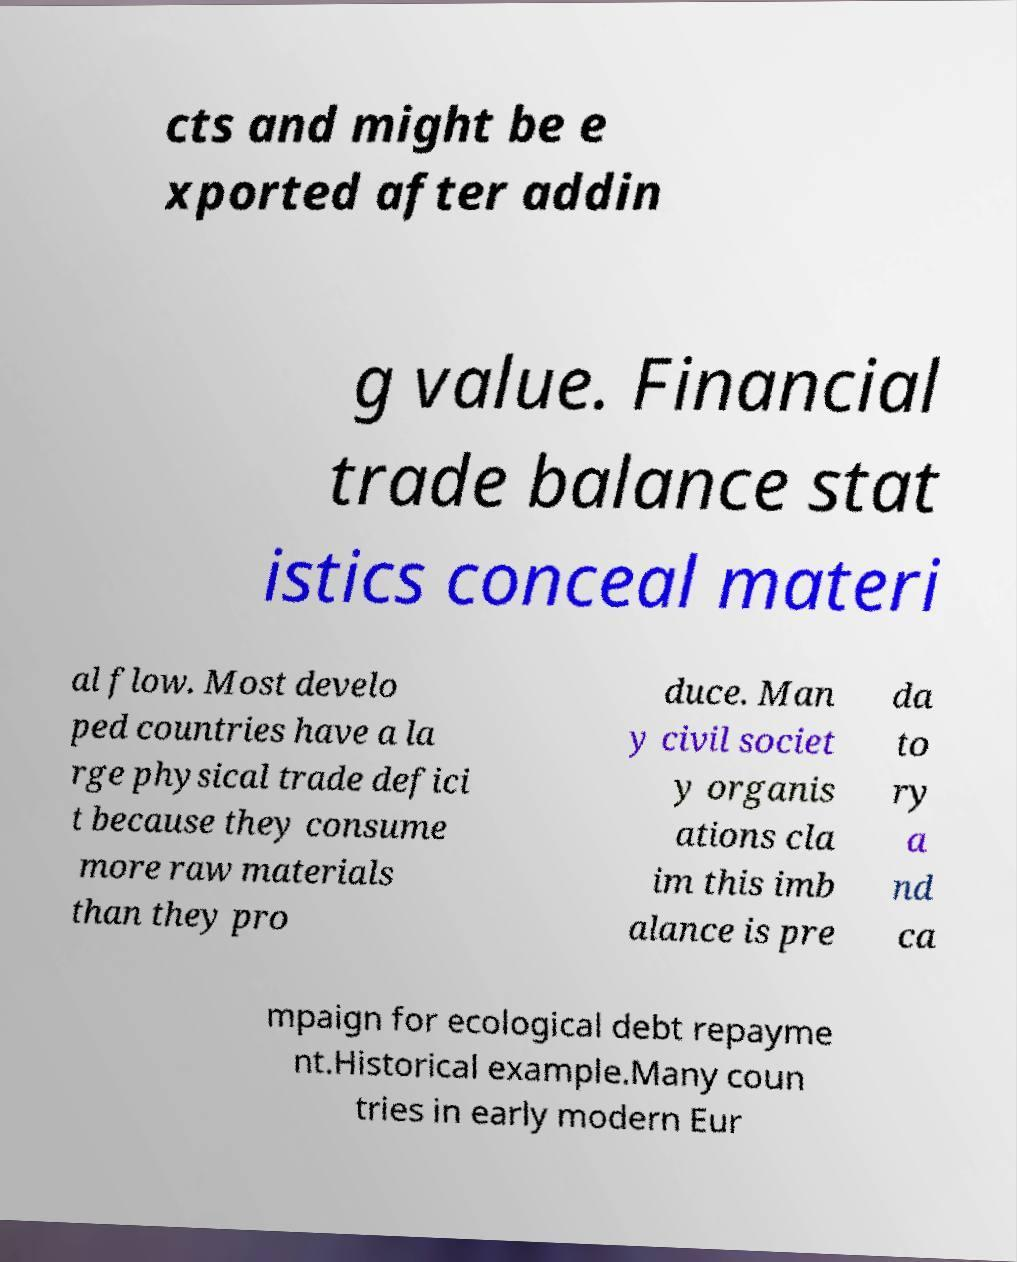Please read and relay the text visible in this image. What does it say? cts and might be e xported after addin g value. Financial trade balance stat istics conceal materi al flow. Most develo ped countries have a la rge physical trade defici t because they consume more raw materials than they pro duce. Man y civil societ y organis ations cla im this imb alance is pre da to ry a nd ca mpaign for ecological debt repayme nt.Historical example.Many coun tries in early modern Eur 